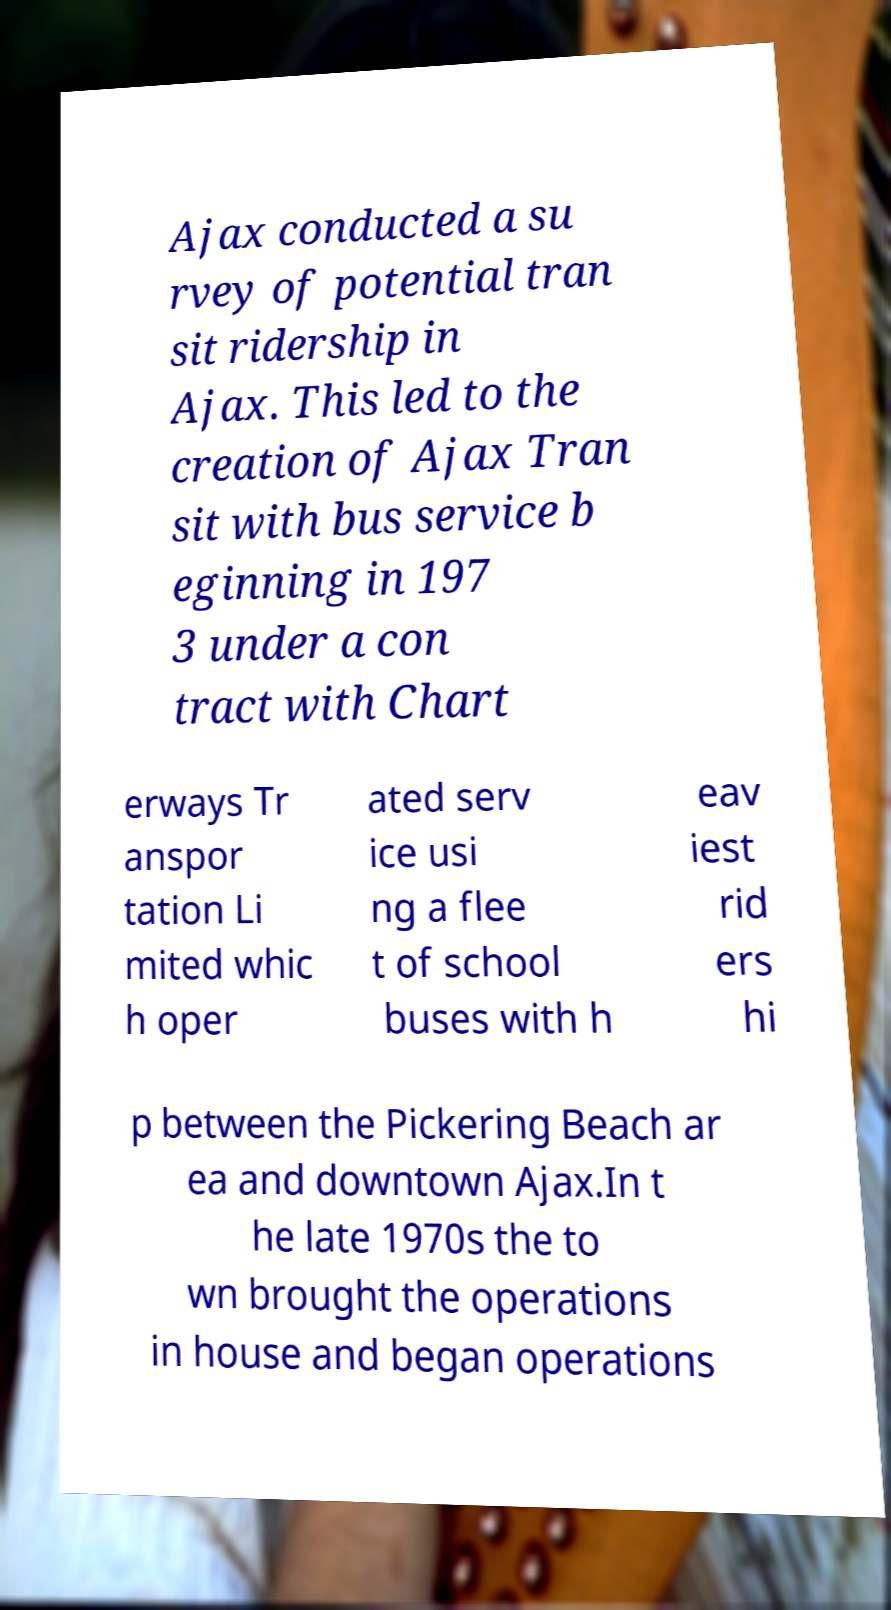Please read and relay the text visible in this image. What does it say? Ajax conducted a su rvey of potential tran sit ridership in Ajax. This led to the creation of Ajax Tran sit with bus service b eginning in 197 3 under a con tract with Chart erways Tr anspor tation Li mited whic h oper ated serv ice usi ng a flee t of school buses with h eav iest rid ers hi p between the Pickering Beach ar ea and downtown Ajax.In t he late 1970s the to wn brought the operations in house and began operations 